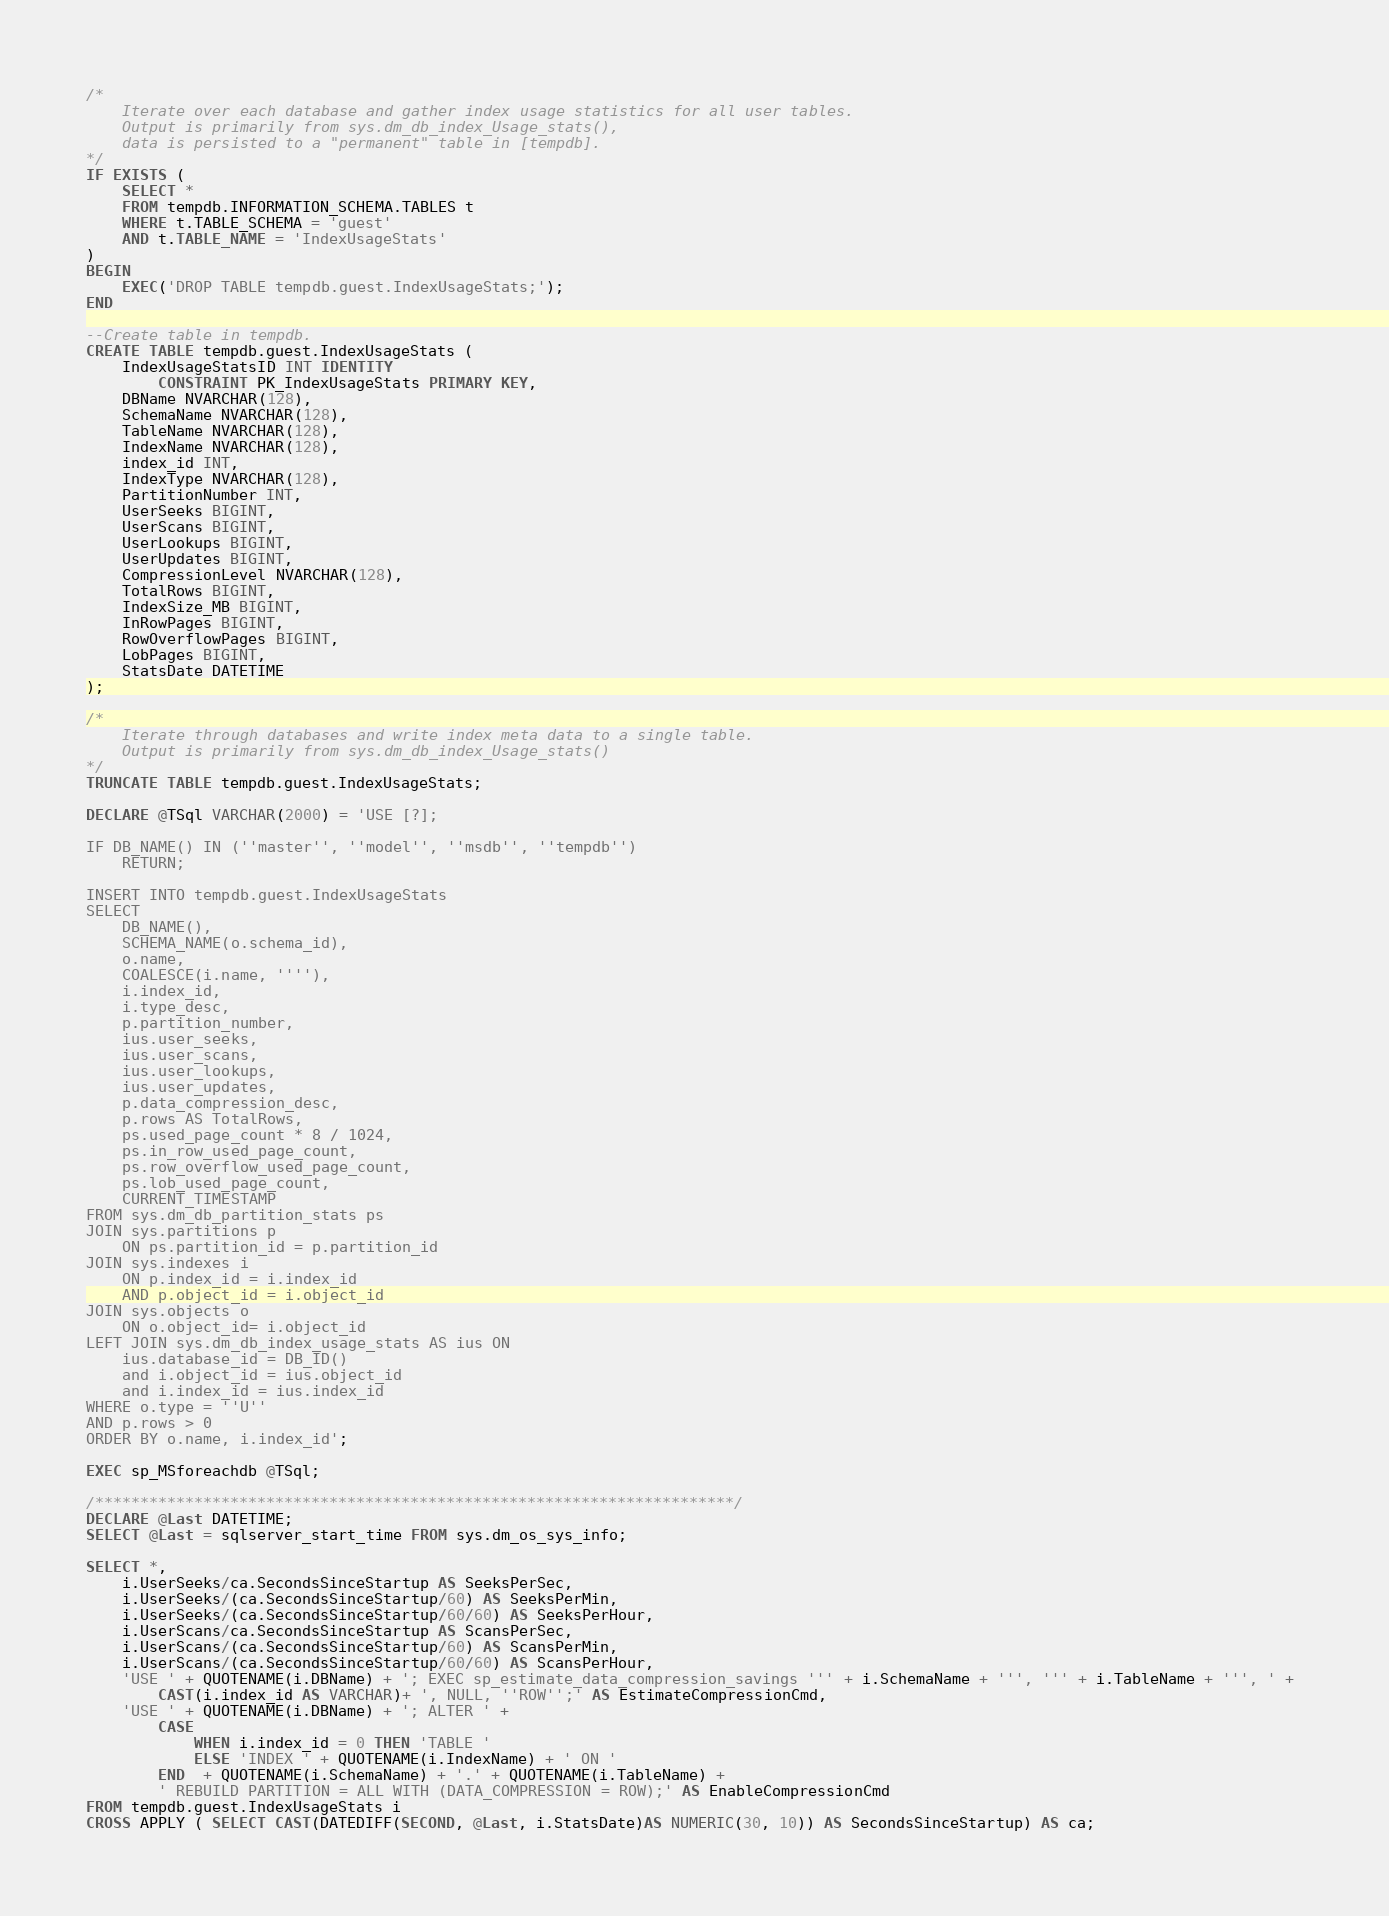<code> <loc_0><loc_0><loc_500><loc_500><_SQL_>/*
	Iterate over each database and gather index usage statistics for all user tables.
	Output is primarily from sys.dm_db_index_Usage_stats(),
	data is persisted to a "permanent" table in [tempdb].
*/
IF EXISTS (
	SELECT *
	FROM tempdb.INFORMATION_SCHEMA.TABLES t
	WHERE t.TABLE_SCHEMA = 'guest'
	AND t.TABLE_NAME = 'IndexUsageStats'
)
BEGIN
	EXEC('DROP TABLE tempdb.guest.IndexUsageStats;');
END

--Create table in tempdb.
CREATE TABLE tempdb.guest.IndexUsageStats (
	IndexUsageStatsID INT IDENTITY 
		CONSTRAINT PK_IndexUsageStats PRIMARY KEY,
	DBName NVARCHAR(128),
	SchemaName NVARCHAR(128),
	TableName NVARCHAR(128),
	IndexName NVARCHAR(128),
	index_id INT,
	IndexType NVARCHAR(128),
	PartitionNumber INT,
	UserSeeks BIGINT,
    UserScans BIGINT,
    UserLookups BIGINT,
    UserUpdates BIGINT,
	CompressionLevel NVARCHAR(128),
	TotalRows BIGINT,
	IndexSize_MB BIGINT,
	InRowPages BIGINT,
	RowOverflowPages BIGINT,
	LobPages BIGINT,
	StatsDate DATETIME
);

/*
	Iterate through databases and write index meta data to a single table.
	Output is primarily from sys.dm_db_index_Usage_stats()
*/
TRUNCATE TABLE tempdb.guest.IndexUsageStats;

DECLARE @TSql VARCHAR(2000) = 'USE [?]; 

IF DB_NAME() IN (''master'', ''model'', ''msdb'', ''tempdb'')
	RETURN;

INSERT INTO tempdb.guest.IndexUsageStats
SELECT 
	DB_NAME(),
	SCHEMA_NAME(o.schema_id),
	o.name,
	COALESCE(i.name, ''''),
	i.index_id,
	i.type_desc,
	p.partition_number,
	ius.user_seeks,
    ius.user_scans,
    ius.user_lookups,
    ius.user_updates,
	p.data_compression_desc,
	p.rows AS TotalRows,
	ps.used_page_count * 8 / 1024,
	ps.in_row_used_page_count,
	ps.row_overflow_used_page_count,
	ps.lob_used_page_count,
	CURRENT_TIMESTAMP
FROM sys.dm_db_partition_stats ps
JOIN sys.partitions p 
	ON ps.partition_id = p.partition_id
JOIN sys.indexes i 
	ON p.index_id = i.index_id 
	AND p.object_id = i.object_id
JOIN sys.objects o 
	ON o.object_id= i.object_id
LEFT JOIN sys.dm_db_index_usage_stats AS ius ON 
    ius.database_id = DB_ID() 
    and i.object_id = ius.object_id 
    and i.index_id = ius.index_id
WHERE o.type = ''U''
AND p.rows > 0
ORDER BY o.name, i.index_id';

EXEC sp_MSforeachdb @TSql;

/***********************************************************************/
DECLARE @Last DATETIME;
SELECT @Last = sqlserver_start_time FROM sys.dm_os_sys_info;

SELECT *,
	i.UserSeeks/ca.SecondsSinceStartup AS SeeksPerSec,
	i.UserSeeks/(ca.SecondsSinceStartup/60) AS SeeksPerMin,
	i.UserSeeks/(ca.SecondsSinceStartup/60/60) AS SeeksPerHour,
	i.UserScans/ca.SecondsSinceStartup AS ScansPerSec,
	i.UserScans/(ca.SecondsSinceStartup/60) AS ScansPerMin,
	i.UserScans/(ca.SecondsSinceStartup/60/60) AS ScansPerHour,
	'USE ' + QUOTENAME(i.DBName) + '; EXEC sp_estimate_data_compression_savings ''' + i.SchemaName + ''', ''' + i.TableName + ''', ' + 
		CAST(i.index_id AS VARCHAR)+ ', NULL, ''ROW'';' AS EstimateCompressionCmd,
	'USE ' + QUOTENAME(i.DBName) + '; ALTER ' +
		CASE 
			WHEN i.index_id = 0 THEN 'TABLE '
			ELSE 'INDEX ' + QUOTENAME(i.IndexName) + ' ON ' 
		END  + QUOTENAME(i.SchemaName) + '.' + QUOTENAME(i.TableName) + 
		' REBUILD PARTITION = ALL WITH (DATA_COMPRESSION = ROW);' AS EnableCompressionCmd
FROM tempdb.guest.IndexUsageStats i
CROSS APPLY ( SELECT CAST(DATEDIFF(SECOND, @Last, i.StatsDate)AS NUMERIC(30, 10)) AS SecondsSinceStartup) AS ca;
</code> 